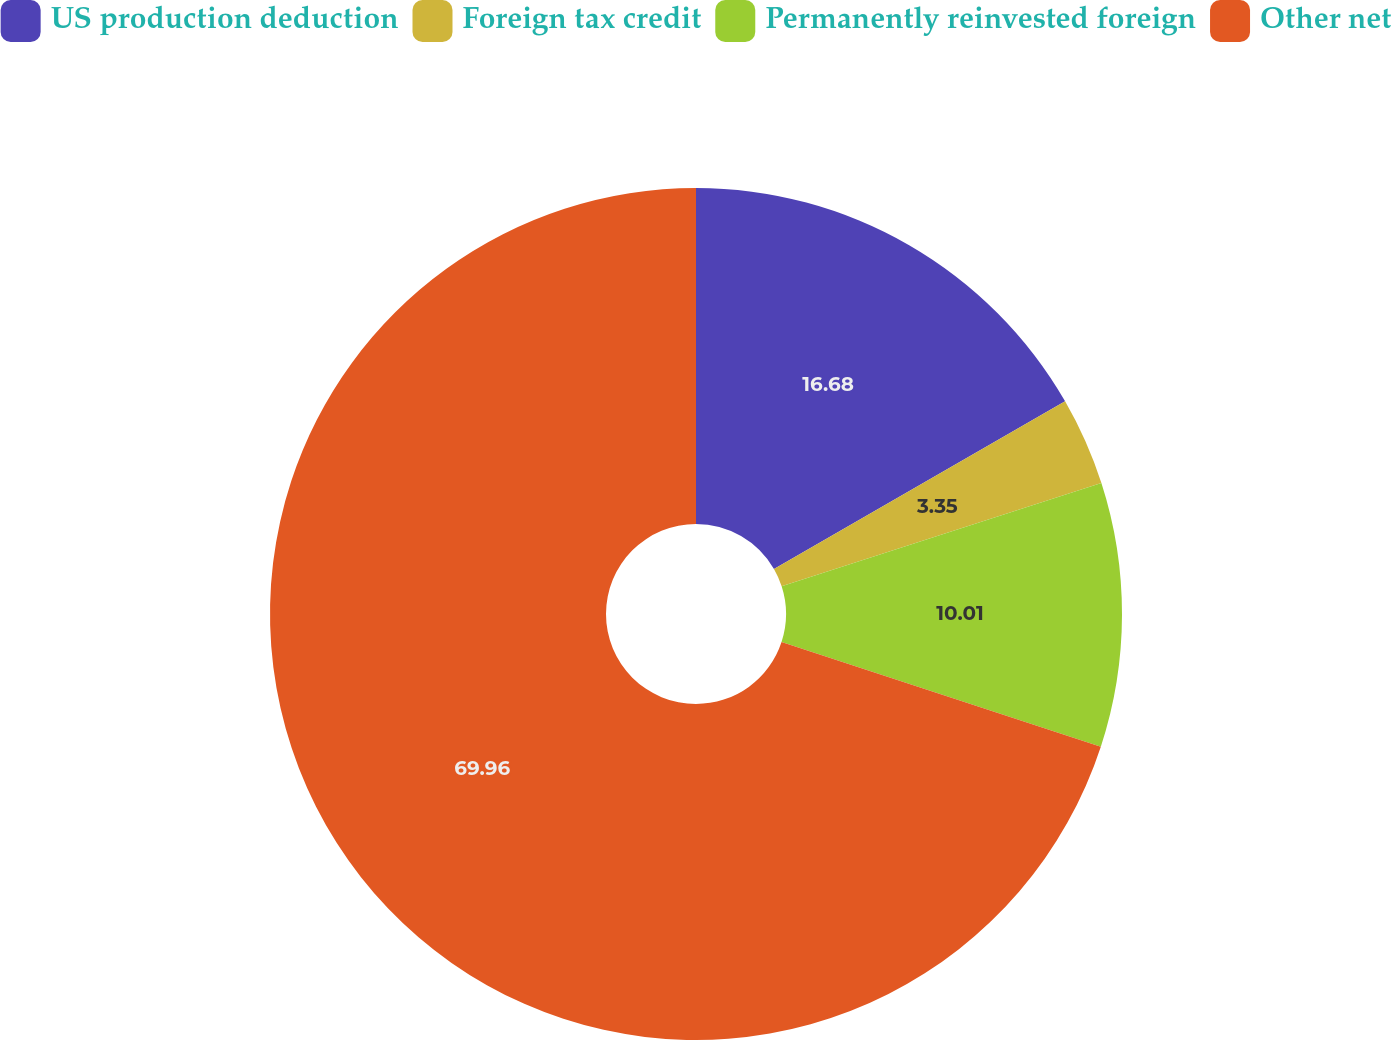Convert chart to OTSL. <chart><loc_0><loc_0><loc_500><loc_500><pie_chart><fcel>US production deduction<fcel>Foreign tax credit<fcel>Permanently reinvested foreign<fcel>Other net<nl><fcel>16.68%<fcel>3.35%<fcel>10.01%<fcel>69.96%<nl></chart> 